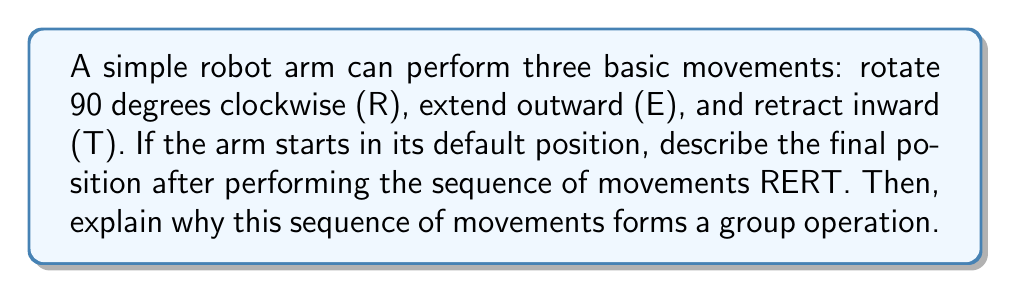Solve this math problem. Let's break this down step-by-step:

1. Starting position: The arm is in its default position.

2. R (Rotate 90 degrees clockwise): The arm is now pointing to the right.

3. E (Extend outward): The arm extends while pointing to the right.

4. R (Rotate 90 degrees clockwise): The arm is now pointing downward and extended.

5. T (Retract inward): The arm retracts while pointing downward.

Final position: The arm is pointing downward in its retracted position.

Now, let's explain why this sequence of movements forms a group operation:

1. Closure: Any sequence of these movements will always result in a valid position for the robot arm. The set of all possible arm positions is closed under these operations.

2. Associativity: The order of applying multiple sequences of movements doesn't matter. For example, (RERT)RE = RE(RTRE).

3. Identity element: There's a "do nothing" movement (let's call it I) that leaves the arm in its current position. RERT * I = I * RERT = RERT.

4. Inverse element: Each movement has an inverse:
   - R^-1 = RRR (rotate 270 degrees clockwise, or 90 degrees counterclockwise)
   - E^-1 = T
   - T^-1 = E
   The sequence RERT can be reversed by TRER, bringing the arm back to its starting position.

These properties satisfy the four group axioms, making the set of robot arm movements under composition a group.
Answer: The final position of the robot arm is pointing downward in its retracted position. The sequence RERT forms a group operation because it satisfies the four group axioms: closure, associativity, identity element, and inverse element. 